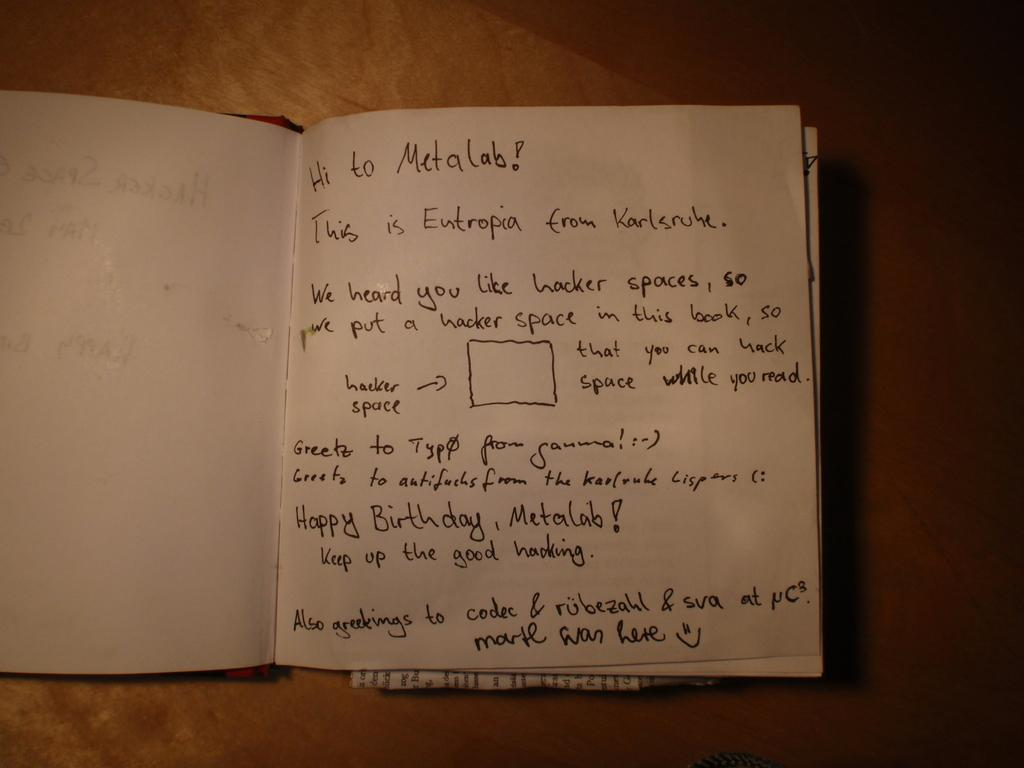<image>
Write a terse but informative summary of the picture. a letter that starts off with 'hi to metalab!' 